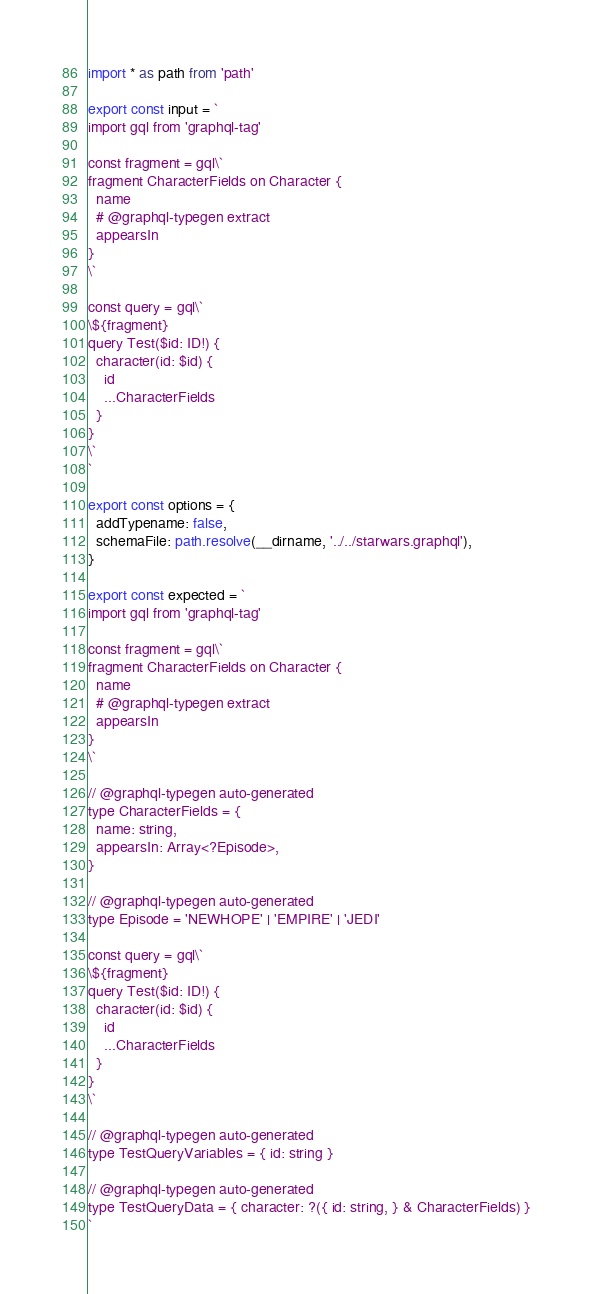<code> <loc_0><loc_0><loc_500><loc_500><_TypeScript_>import * as path from 'path'

export const input = `
import gql from 'graphql-tag'

const fragment = gql\`
fragment CharacterFields on Character {
  name
  # @graphql-typegen extract
  appearsIn
}
\`

const query = gql\`
\${fragment}
query Test($id: ID!) {
  character(id: $id) {
    id
    ...CharacterFields
  }
}
\`
`

export const options = {
  addTypename: false,
  schemaFile: path.resolve(__dirname, '../../starwars.graphql'),
}

export const expected = `
import gql from 'graphql-tag'

const fragment = gql\`
fragment CharacterFields on Character {
  name
  # @graphql-typegen extract
  appearsIn
}
\`

// @graphql-typegen auto-generated
type CharacterFields = {
  name: string,
  appearsIn: Array<?Episode>,
}

// @graphql-typegen auto-generated
type Episode = 'NEWHOPE' | 'EMPIRE' | 'JEDI'

const query = gql\`
\${fragment}
query Test($id: ID!) {
  character(id: $id) {
    id
    ...CharacterFields
  }
}
\`

// @graphql-typegen auto-generated
type TestQueryVariables = { id: string }

// @graphql-typegen auto-generated
type TestQueryData = { character: ?({ id: string, } & CharacterFields) }
`
</code> 